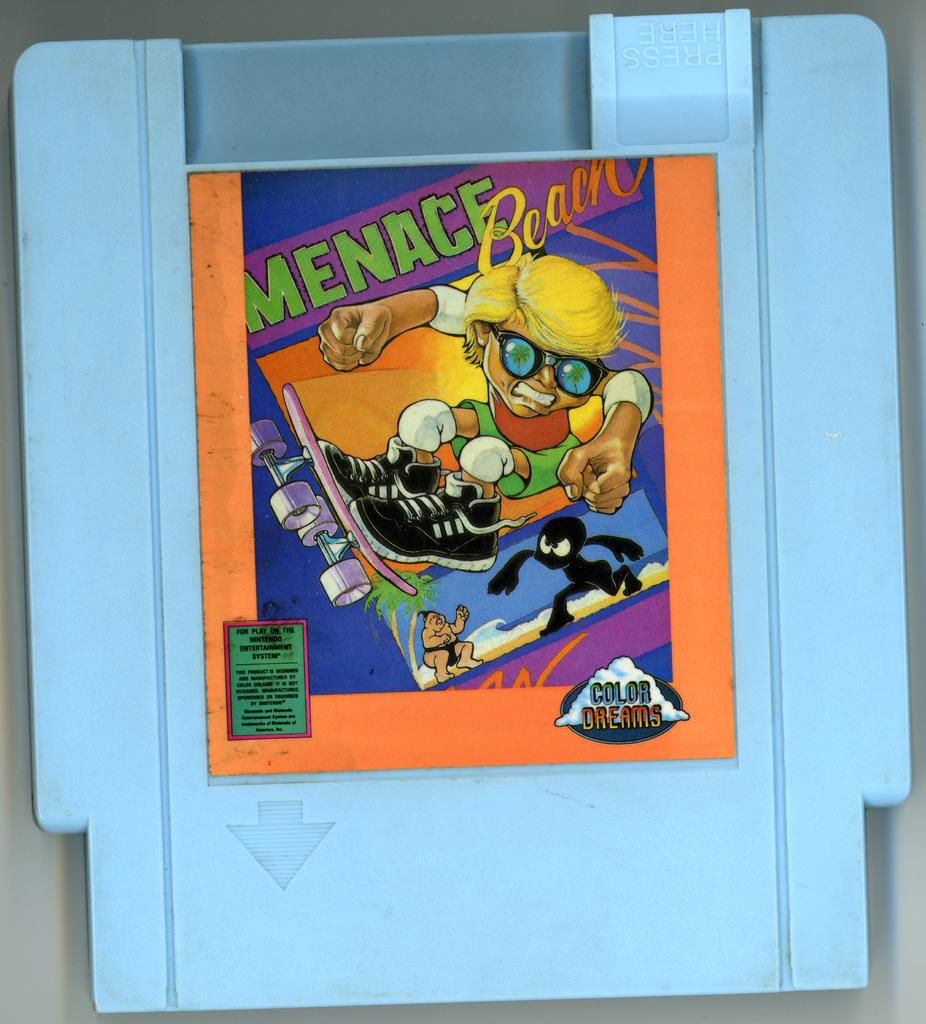What is featured on the poster in the image? The poster in the image has both text and images on it. What is the blue object associated with the poster? The blue object is associated with the poster, but the specific nature of the association is not clear from the facts provided. Can you describe the text on the poster? The facts provided do not give specific details about the text on the poster. What type of toothpaste is being discussed in the poster? There is no toothpaste mentioned or depicted in the image, so it cannot be determined from the image. 